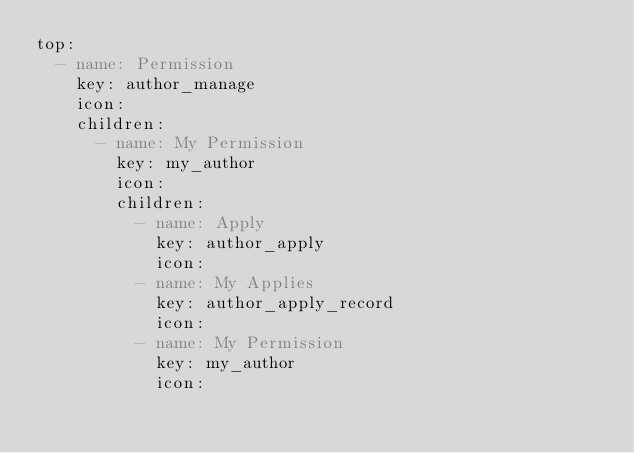Convert code to text. <code><loc_0><loc_0><loc_500><loc_500><_YAML_>top:
  - name: Permission
    key: author_manage
    icon:
    children:
      - name: My Permission
        key: my_author
        icon:
        children:
          - name: Apply
            key: author_apply
            icon:
          - name: My Applies
            key: author_apply_record
            icon:
          - name: My Permission
            key: my_author
            icon:</code> 